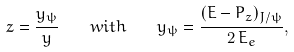<formula> <loc_0><loc_0><loc_500><loc_500>z = \frac { y _ { \psi } } { y } \quad w i t h \quad y _ { \psi } = \frac { ( E - P _ { z } ) _ { J / \psi } } { 2 \, E _ { e } } ,</formula> 